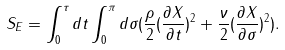<formula> <loc_0><loc_0><loc_500><loc_500>S _ { E } = \int _ { 0 } ^ { \tau } d t \int _ { 0 } ^ { \pi } d \sigma ( \frac { \rho } { 2 } ( \frac { \partial X } { \partial t } ) ^ { 2 } + \frac { \nu } { 2 } ( \frac { \partial X } { \partial \sigma } ) ^ { 2 } ) .</formula> 